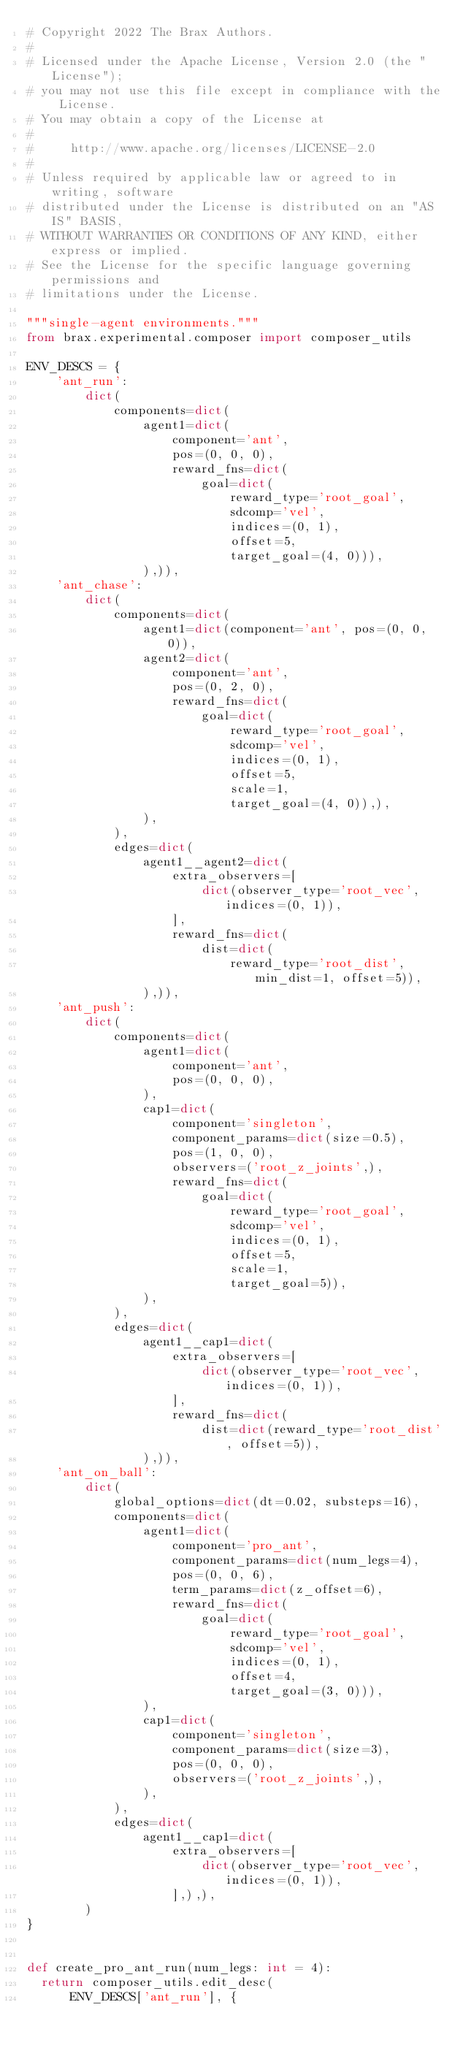Convert code to text. <code><loc_0><loc_0><loc_500><loc_500><_Python_># Copyright 2022 The Brax Authors.
#
# Licensed under the Apache License, Version 2.0 (the "License");
# you may not use this file except in compliance with the License.
# You may obtain a copy of the License at
#
#     http://www.apache.org/licenses/LICENSE-2.0
#
# Unless required by applicable law or agreed to in writing, software
# distributed under the License is distributed on an "AS IS" BASIS,
# WITHOUT WARRANTIES OR CONDITIONS OF ANY KIND, either express or implied.
# See the License for the specific language governing permissions and
# limitations under the License.

"""single-agent environments."""
from brax.experimental.composer import composer_utils

ENV_DESCS = {
    'ant_run':
        dict(
            components=dict(
                agent1=dict(
                    component='ant',
                    pos=(0, 0, 0),
                    reward_fns=dict(
                        goal=dict(
                            reward_type='root_goal',
                            sdcomp='vel',
                            indices=(0, 1),
                            offset=5,
                            target_goal=(4, 0))),
                ),)),
    'ant_chase':
        dict(
            components=dict(
                agent1=dict(component='ant', pos=(0, 0, 0)),
                agent2=dict(
                    component='ant',
                    pos=(0, 2, 0),
                    reward_fns=dict(
                        goal=dict(
                            reward_type='root_goal',
                            sdcomp='vel',
                            indices=(0, 1),
                            offset=5,
                            scale=1,
                            target_goal=(4, 0)),),
                ),
            ),
            edges=dict(
                agent1__agent2=dict(
                    extra_observers=[
                        dict(observer_type='root_vec', indices=(0, 1)),
                    ],
                    reward_fns=dict(
                        dist=dict(
                            reward_type='root_dist', min_dist=1, offset=5)),
                ),)),
    'ant_push':
        dict(
            components=dict(
                agent1=dict(
                    component='ant',
                    pos=(0, 0, 0),
                ),
                cap1=dict(
                    component='singleton',
                    component_params=dict(size=0.5),
                    pos=(1, 0, 0),
                    observers=('root_z_joints',),
                    reward_fns=dict(
                        goal=dict(
                            reward_type='root_goal',
                            sdcomp='vel',
                            indices=(0, 1),
                            offset=5,
                            scale=1,
                            target_goal=5)),
                ),
            ),
            edges=dict(
                agent1__cap1=dict(
                    extra_observers=[
                        dict(observer_type='root_vec', indices=(0, 1)),
                    ],
                    reward_fns=dict(
                        dist=dict(reward_type='root_dist', offset=5)),
                ),)),
    'ant_on_ball':
        dict(
            global_options=dict(dt=0.02, substeps=16),
            components=dict(
                agent1=dict(
                    component='pro_ant',
                    component_params=dict(num_legs=4),
                    pos=(0, 0, 6),
                    term_params=dict(z_offset=6),
                    reward_fns=dict(
                        goal=dict(
                            reward_type='root_goal',
                            sdcomp='vel',
                            indices=(0, 1),
                            offset=4,
                            target_goal=(3, 0))),
                ),
                cap1=dict(
                    component='singleton',
                    component_params=dict(size=3),
                    pos=(0, 0, 0),
                    observers=('root_z_joints',),
                ),
            ),
            edges=dict(
                agent1__cap1=dict(
                    extra_observers=[
                        dict(observer_type='root_vec', indices=(0, 1)),
                    ],),),
        )
}


def create_pro_ant_run(num_legs: int = 4):
  return composer_utils.edit_desc(
      ENV_DESCS['ant_run'], {</code> 